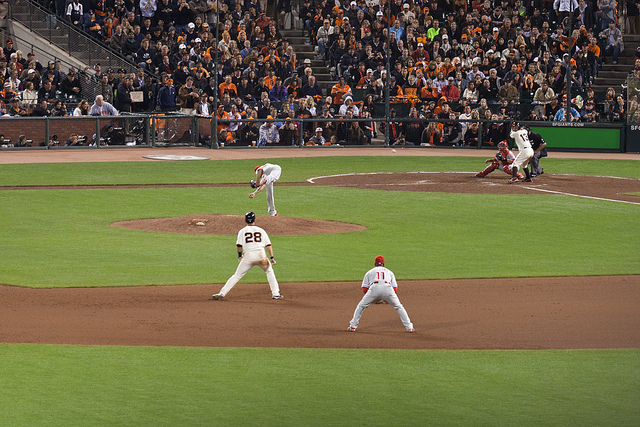Extract all visible text content from this image. 11 28 